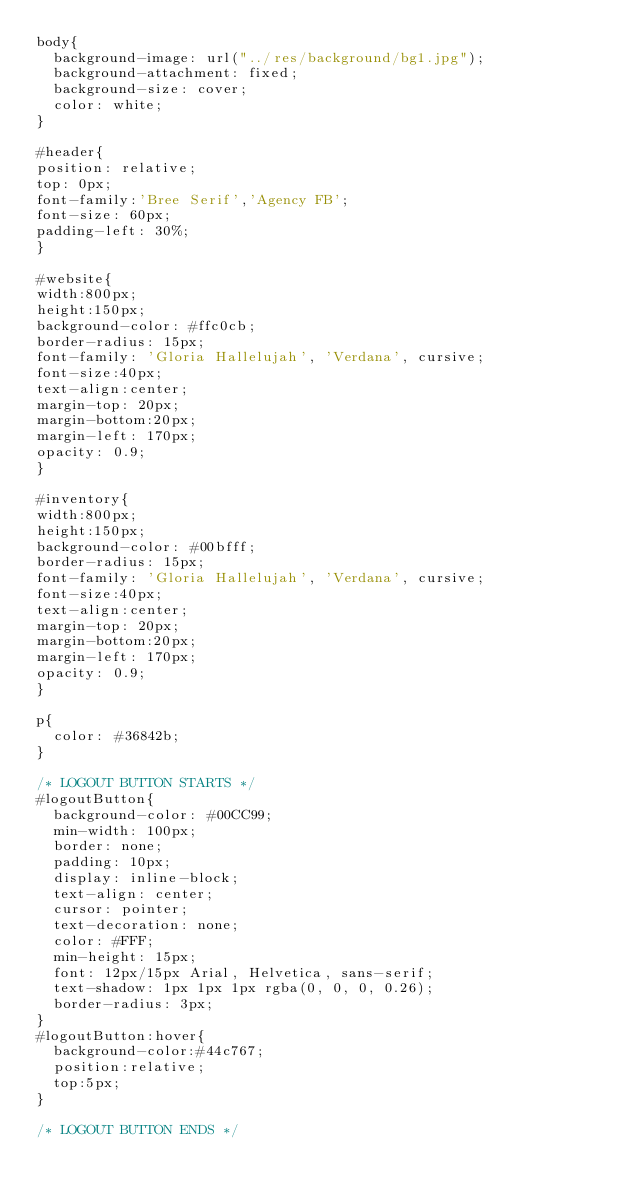<code> <loc_0><loc_0><loc_500><loc_500><_CSS_>body{
	background-image: url("../res/background/bg1.jpg");
	background-attachment: fixed;
	background-size: cover;
	color: white;	
}

#header{
position: relative;
top: 0px;
font-family:'Bree Serif','Agency FB';
font-size: 60px;
padding-left: 30%;
}

#website{
width:800px;
height:150px;
background-color: #ffc0cb;
border-radius: 15px;
font-family: 'Gloria Hallelujah', 'Verdana', cursive;
font-size:40px;
text-align:center;
margin-top: 20px;
margin-bottom:20px;
margin-left: 170px;
opacity: 0.9;
}

#inventory{
width:800px;
height:150px;
background-color: #00bfff;
border-radius: 15px;
font-family: 'Gloria Hallelujah', 'Verdana', cursive;
font-size:40px;
text-align:center;
margin-top: 20px;
margin-bottom:20px;
margin-left: 170px;
opacity: 0.9;
}

p{
	color: #36842b;
}

/* LOGOUT BUTTON STARTS */
#logoutButton{
	background-color: #00CC99;
	min-width: 100px;
	border: none;
	padding: 10px;
	display: inline-block;
	text-align: center;
	cursor: pointer;
	text-decoration: none;
	color: #FFF;
	min-height: 15px;
	font: 12px/15px Arial, Helvetica, sans-serif;
	text-shadow: 1px 1px 1px rgba(0, 0, 0, 0.26);
	border-radius: 3px;
}
#logoutButton:hover{
	background-color:#44c767;
	position:relative;
	top:5px;
}

/* LOGOUT BUTTON ENDS */</code> 